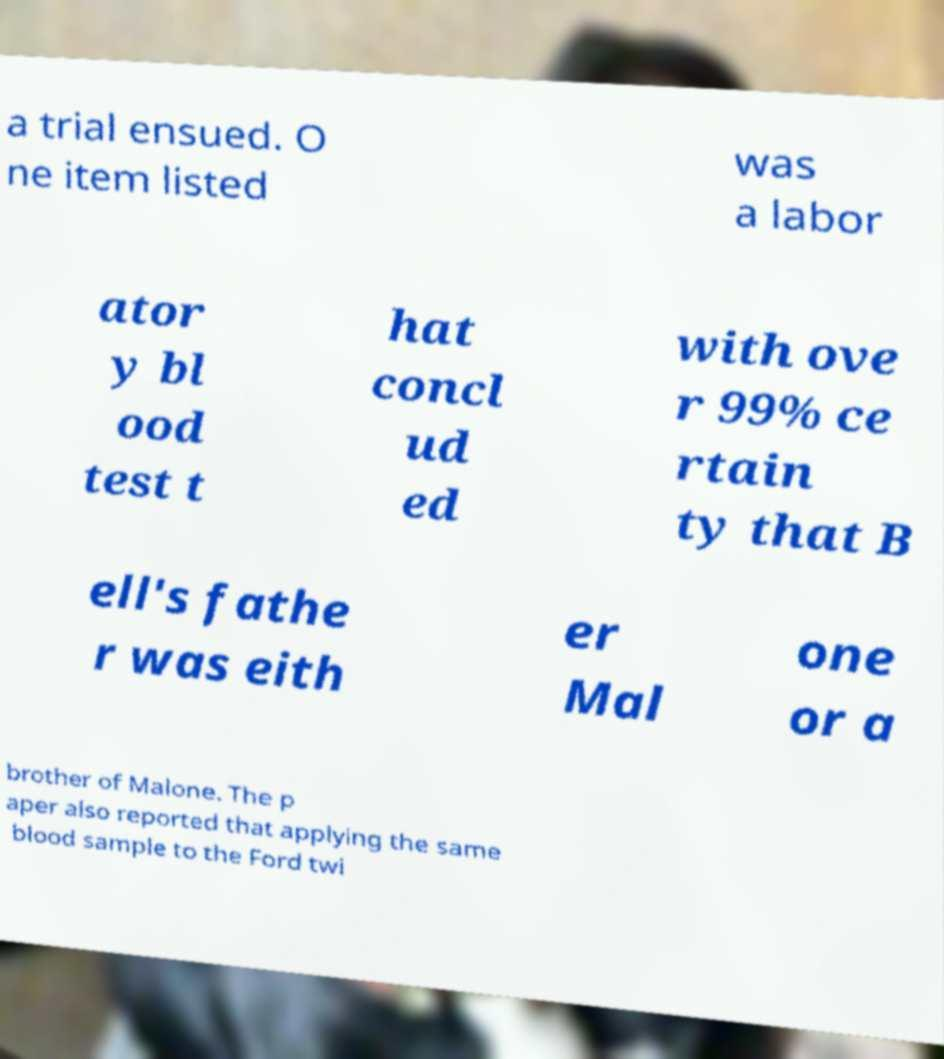Please identify and transcribe the text found in this image. a trial ensued. O ne item listed was a labor ator y bl ood test t hat concl ud ed with ove r 99% ce rtain ty that B ell's fathe r was eith er Mal one or a brother of Malone. The p aper also reported that applying the same blood sample to the Ford twi 